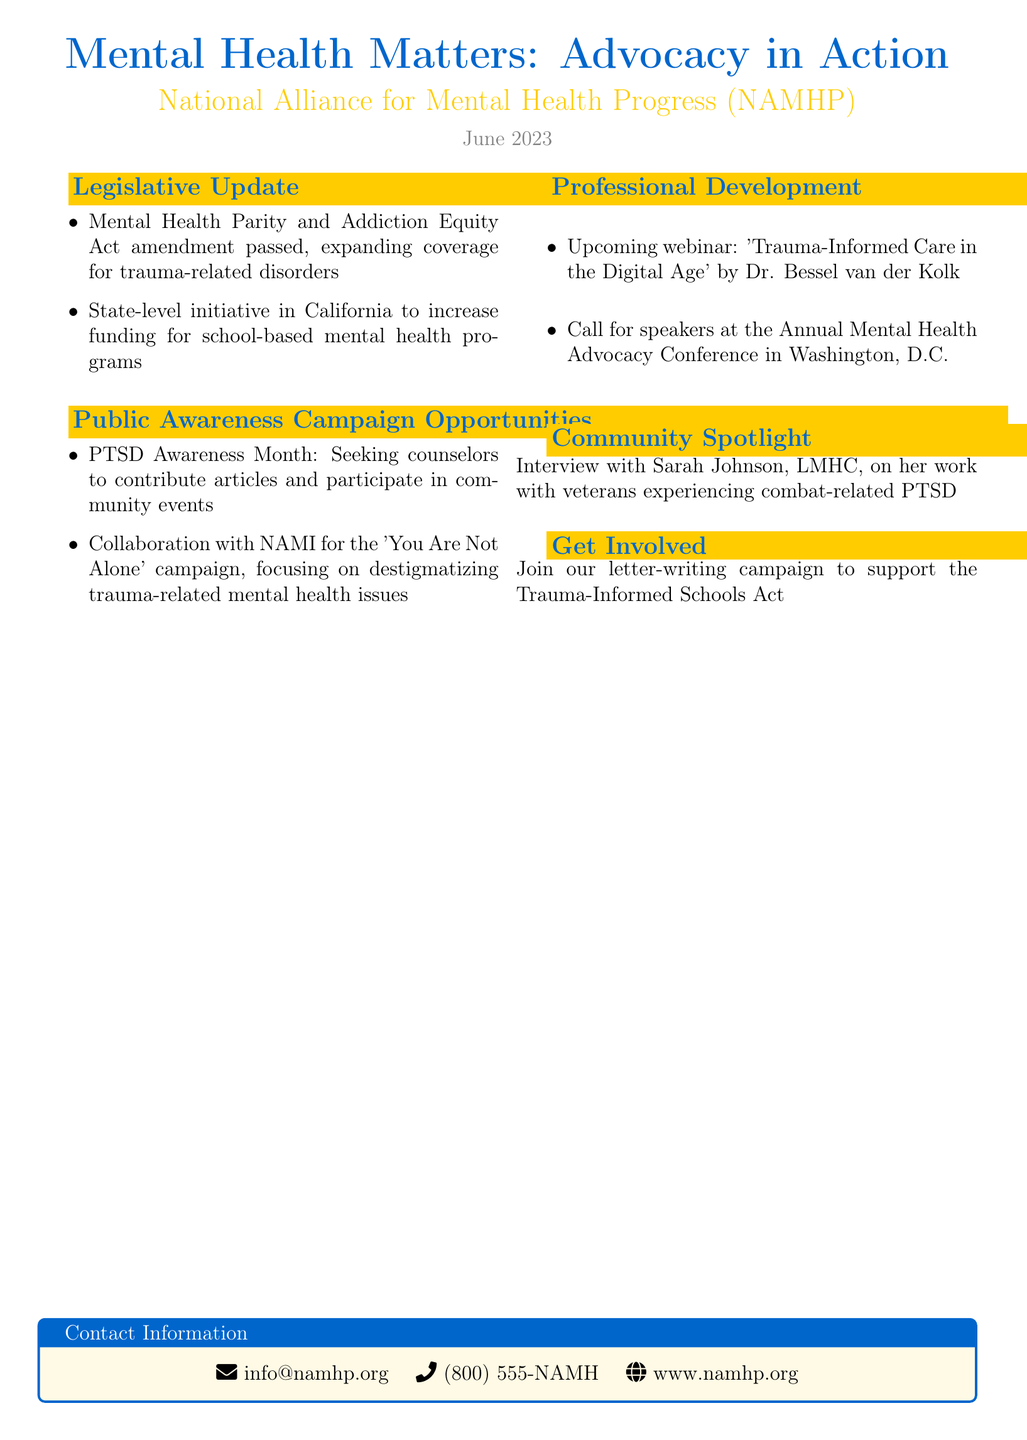what is the title of the newsletter? The title of the newsletter is explicitly stated at the beginning of the document.
Answer: Mental Health Matters: Advocacy in Action who is the organization behind the newsletter? The organization name is mentioned prominently in the document.
Answer: National Alliance for Mental Health Progress (NAMHP) when was the newsletter issued? The date of issue is provided in the document.
Answer: June 2023 what is the focus of the collaboration with NAMI? The content describes the aim of the campaign.
Answer: destigmatizing trauma-related mental health issues who is the featured professional in the Community Spotlight? The document provides the name of the professional in this section.
Answer: Sarah Johnson what legislation was recently amended according to the newsletter? The specific legislation is listed in the Legislative Update section.
Answer: Mental Health Parity and Addiction Equity Act what event is mentioned regarding public awareness? This refers to a specific initiative highlighted in the document.
Answer: PTSD Awareness Month how can counselors get involved with the newsletter’s initiatives? The document outlines specific actions counselors can take.
Answer: join our letter-writing campaign who will present the upcoming webinar? The document specifies the presenter of the webinar.
Answer: Dr. Bessel van der Kolk 